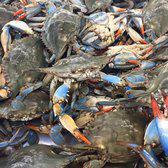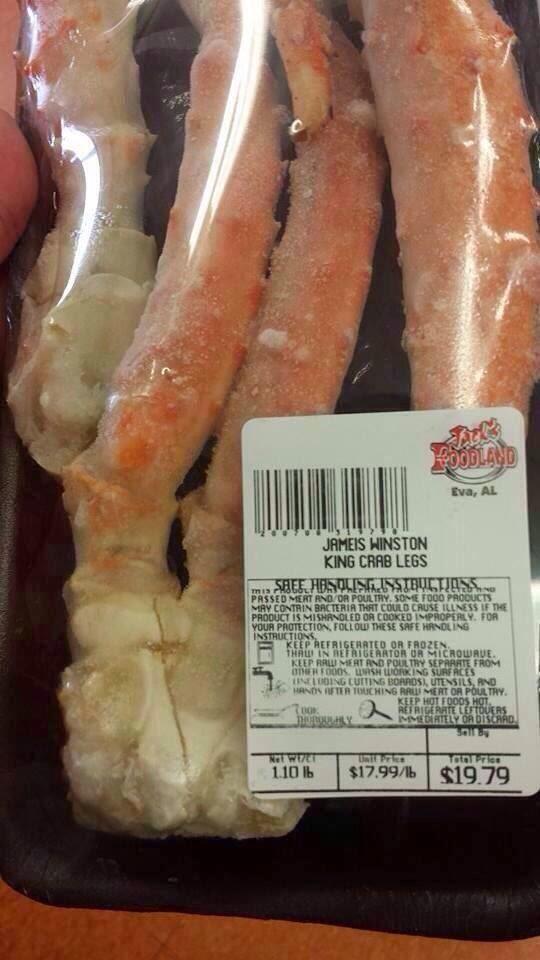The first image is the image on the left, the second image is the image on the right. Assess this claim about the two images: "The crabs in both of the images sit in dishes.". Correct or not? Answer yes or no. No. The first image is the image on the left, the second image is the image on the right. Assess this claim about the two images: "Something yellow is in a round container behind crab legs in one image.". Correct or not? Answer yes or no. No. 